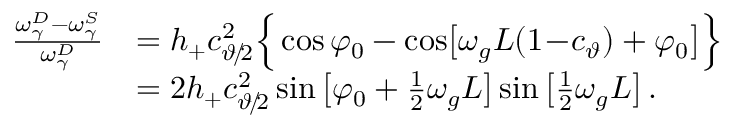<formula> <loc_0><loc_0><loc_500><loc_500>\begin{array} { r l } { \frac { \omega _ { \gamma } ^ { D } - \omega _ { \gamma } ^ { S } } { \omega _ { \gamma } ^ { D } } } & { = h _ { + } c _ { \vartheta \, / \, 2 } ^ { 2 } \left \{ \cos \varphi _ { 0 } - \cos \, \left [ \omega _ { g } L ( 1 \, - \, c _ { \vartheta } ) + \varphi _ { 0 } \right ] \right \} } \\ & { = 2 h _ { + } c _ { \vartheta \, / \, 2 } ^ { 2 } \sin \left [ \varphi _ { 0 } + \frac { 1 } { 2 } \omega _ { g } L \right ] \sin \left [ \frac { 1 } { 2 } \omega _ { g } L \right ] \, . } \end{array}</formula> 